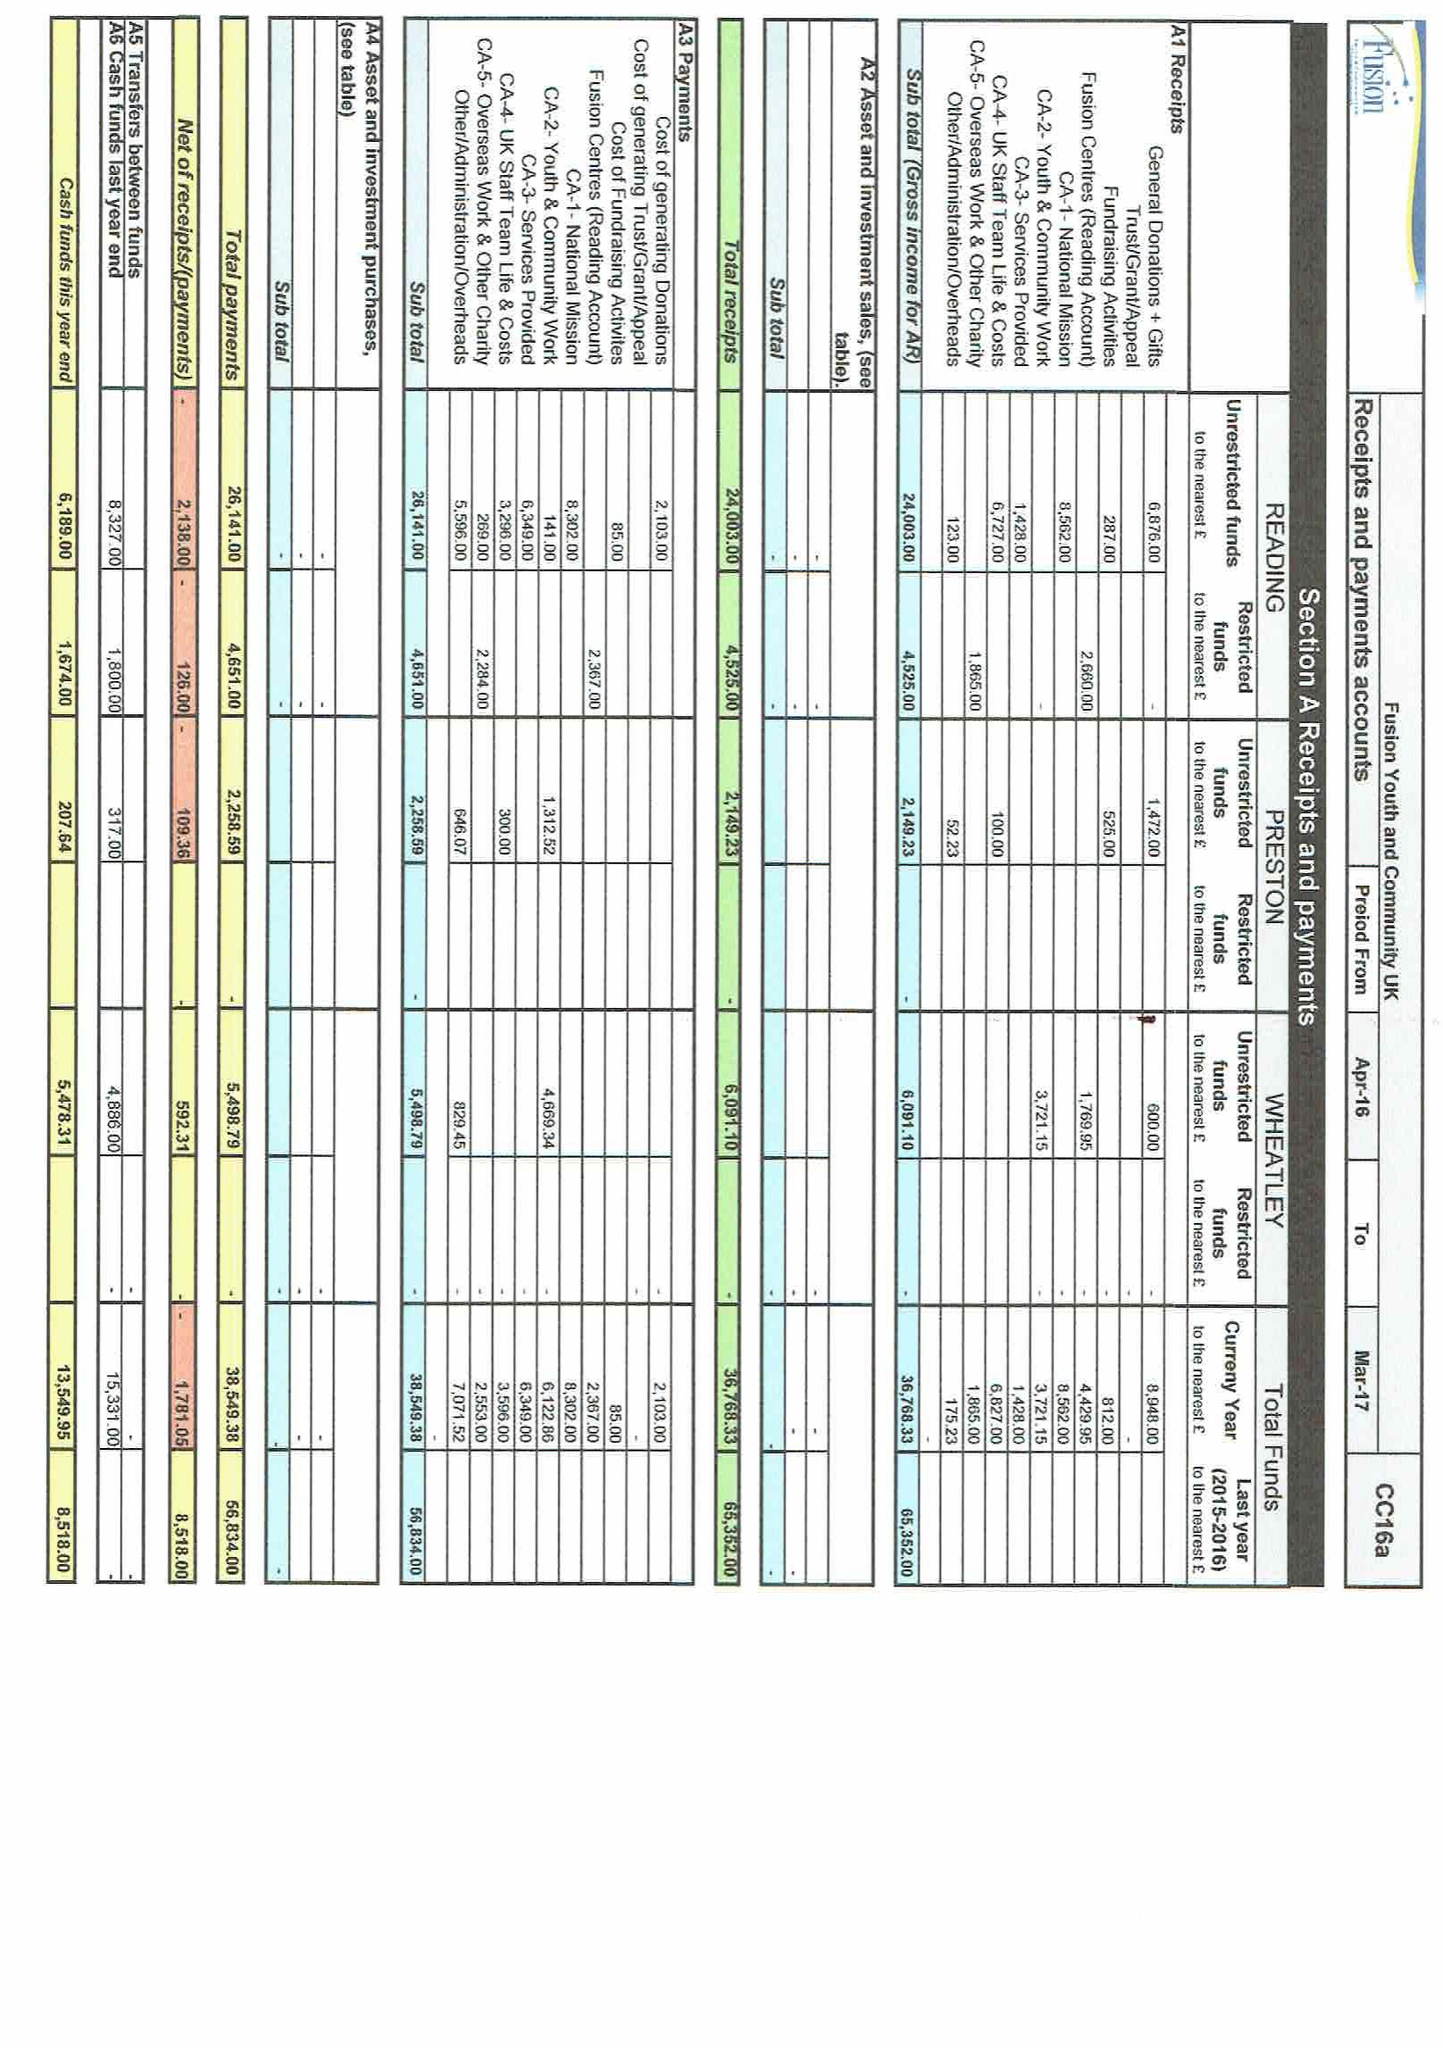What is the value for the report_date?
Answer the question using a single word or phrase. 2017-03-31 